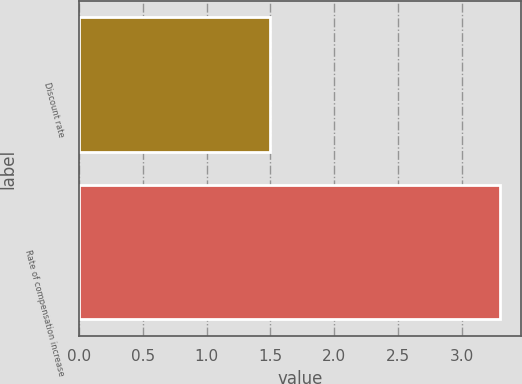Convert chart to OTSL. <chart><loc_0><loc_0><loc_500><loc_500><bar_chart><fcel>Discount rate<fcel>Rate of compensation increase<nl><fcel>1.5<fcel>3.3<nl></chart> 